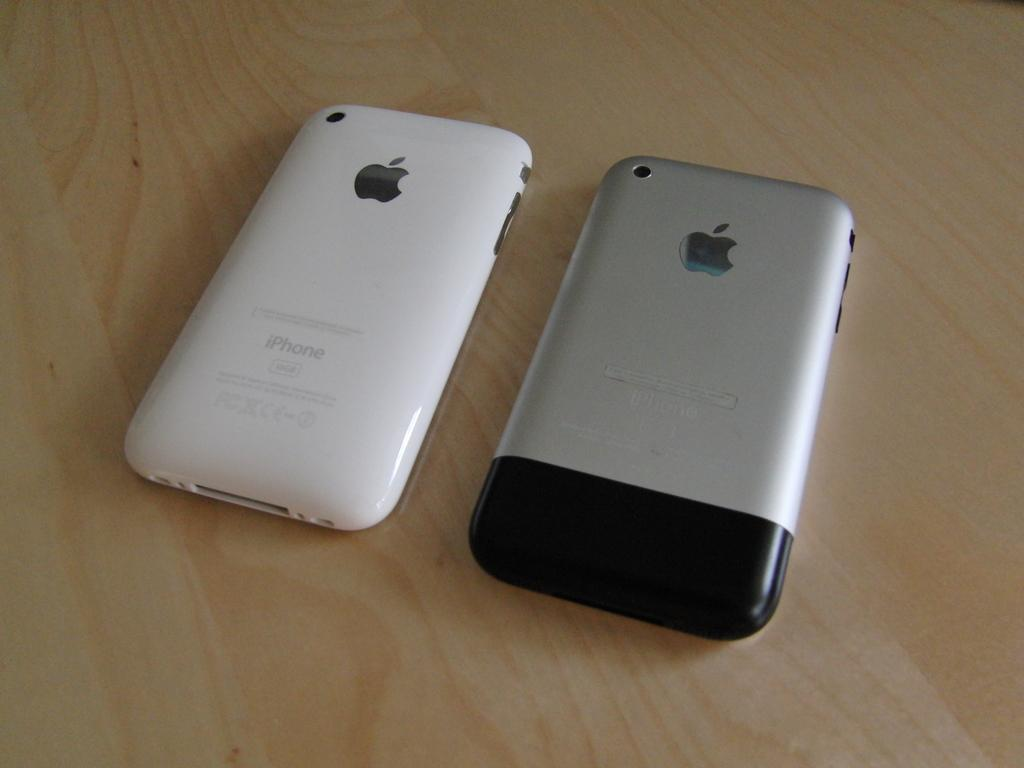<image>
Write a terse but informative summary of the picture. A white iPhone sits next to a silver phone. 